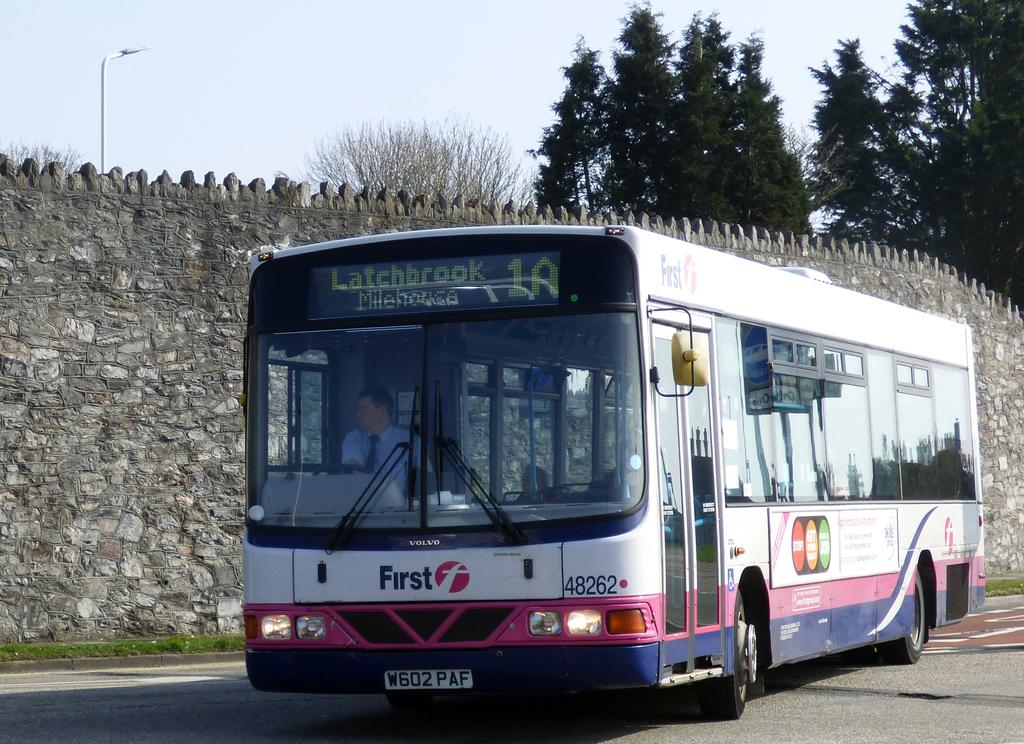What is the main subject of the image? The main subject of the image is a bus. Where is the bus located in the image? The bus is on the road in the image. What feature does the bus have? The bus has a digital screen. What else can be seen in the image besides the bus? There is a wall, a pole, and trees in the image. What type of berry is hanging from the pole in the image? There are no berries present in the image; the pole is a standalone structure. 